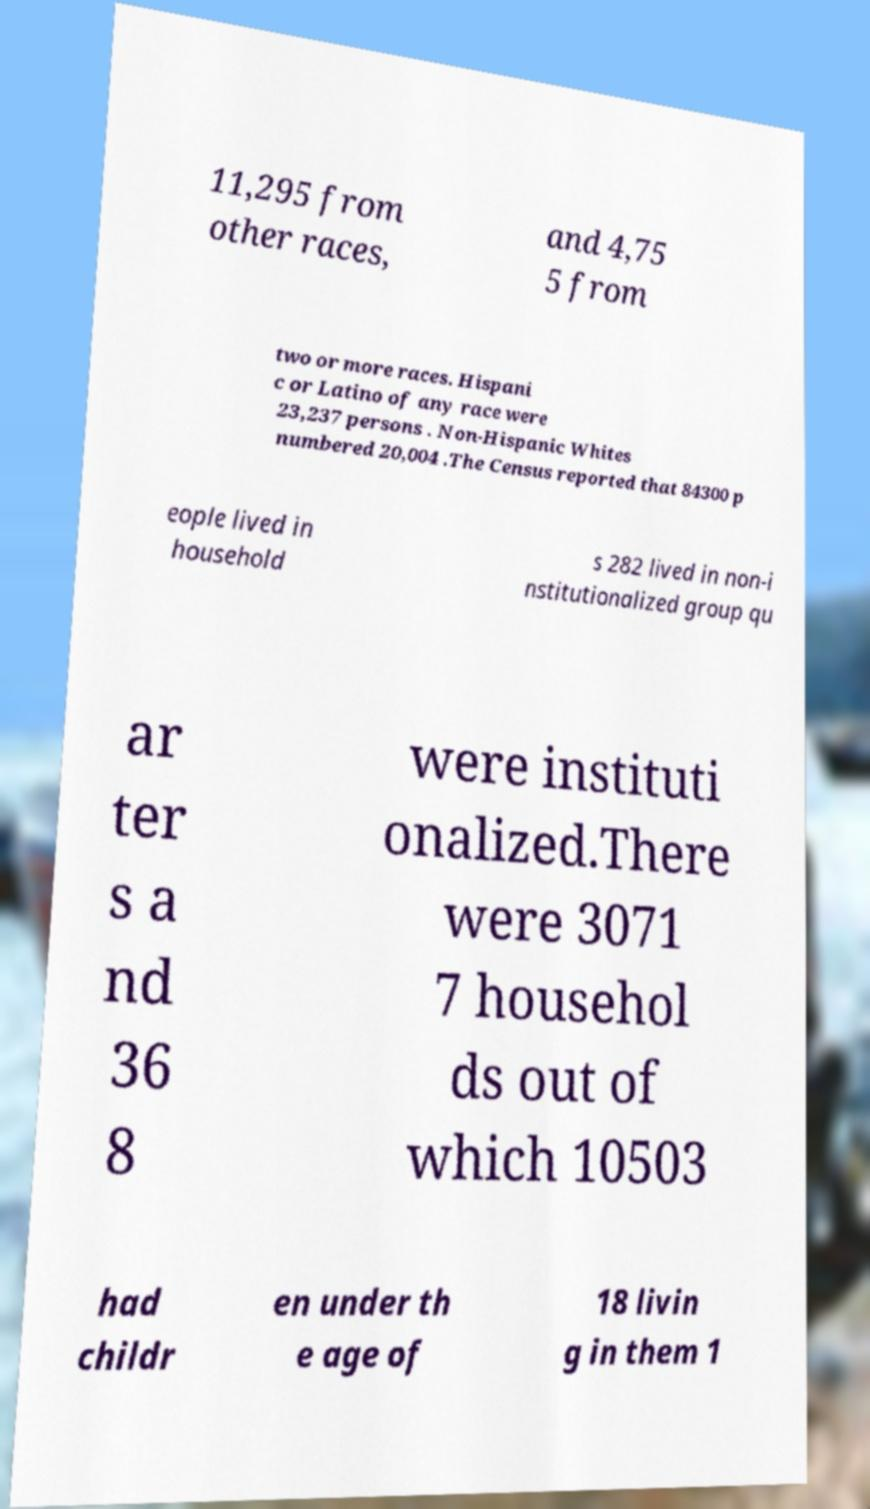Can you accurately transcribe the text from the provided image for me? 11,295 from other races, and 4,75 5 from two or more races. Hispani c or Latino of any race were 23,237 persons . Non-Hispanic Whites numbered 20,004 .The Census reported that 84300 p eople lived in household s 282 lived in non-i nstitutionalized group qu ar ter s a nd 36 8 were instituti onalized.There were 3071 7 househol ds out of which 10503 had childr en under th e age of 18 livin g in them 1 